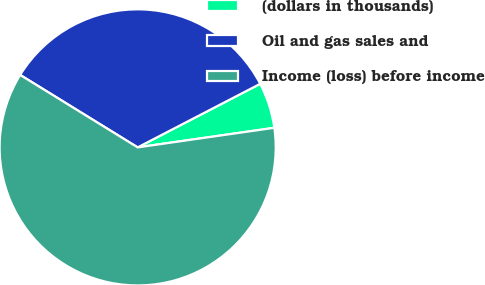Convert chart. <chart><loc_0><loc_0><loc_500><loc_500><pie_chart><fcel>(dollars in thousands)<fcel>Oil and gas sales and<fcel>Income (loss) before income<nl><fcel>5.35%<fcel>33.59%<fcel>61.06%<nl></chart> 